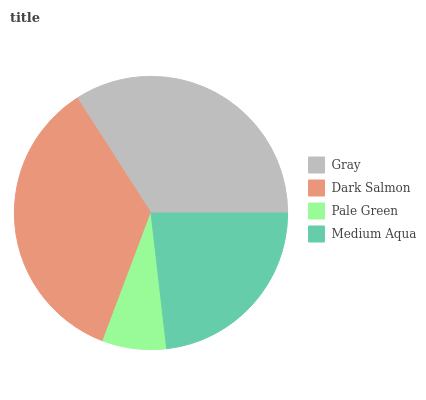Is Pale Green the minimum?
Answer yes or no. Yes. Is Dark Salmon the maximum?
Answer yes or no. Yes. Is Dark Salmon the minimum?
Answer yes or no. No. Is Pale Green the maximum?
Answer yes or no. No. Is Dark Salmon greater than Pale Green?
Answer yes or no. Yes. Is Pale Green less than Dark Salmon?
Answer yes or no. Yes. Is Pale Green greater than Dark Salmon?
Answer yes or no. No. Is Dark Salmon less than Pale Green?
Answer yes or no. No. Is Gray the high median?
Answer yes or no. Yes. Is Medium Aqua the low median?
Answer yes or no. Yes. Is Medium Aqua the high median?
Answer yes or no. No. Is Pale Green the low median?
Answer yes or no. No. 